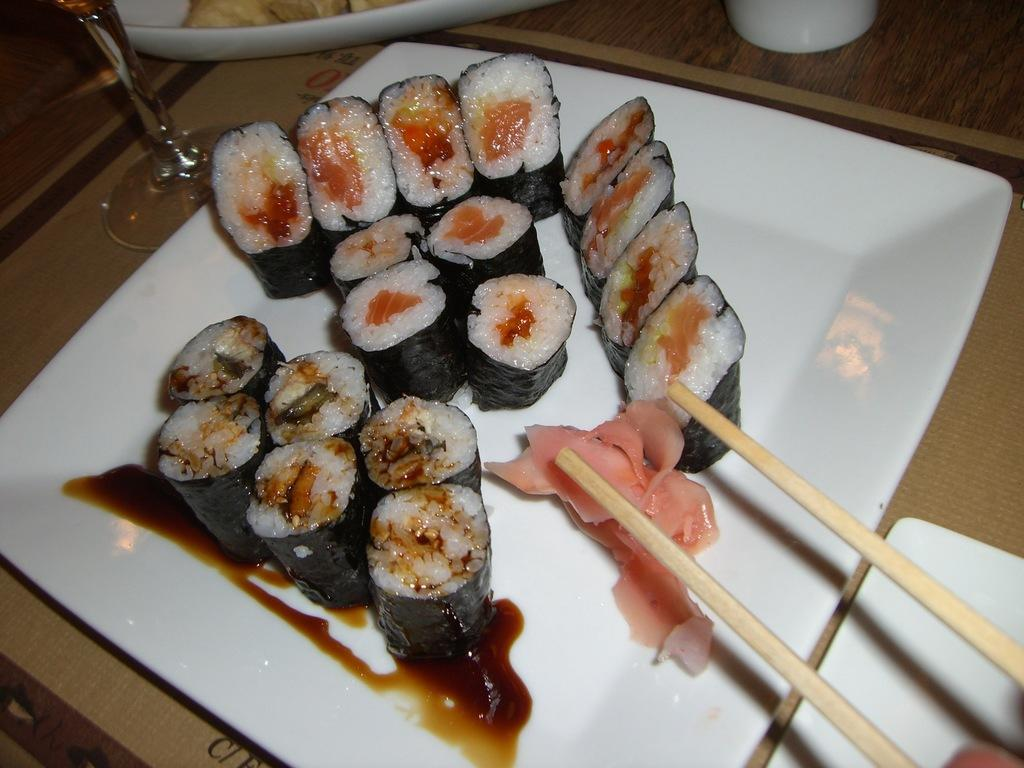What is present on the plate in the image? There is food on the plate in the image. What else can be seen in the image? There is a stick in the image. What language is being spoken by the food on the plate in the image? There is no indication in the image that any language is being spoken. --- Facts: 1. There is a car in the image. 2. The car is red. 3. There is a person standing next to the car. 4. The person is holding a phone. 5. There is a building in the background. Absurd Topics: dinosaur, ocean, volcano Conversation: What is the main subject in the image? There is a car in the image. Can you describe the car in the image? The car is red. What is the person doing next to the car in the image? The person is standing next to the car and holding a phone. What can be seen in the background of the image? There is a building in the background. Reasoning: Let's think step by step in order to produce the conversation. We start by identifying the main subject in the image, which is the car. Then, we describe the specific features of the car, such as its color, which is red. Next, we observe the actions of the person in the image, noting that they are standing next to the car and holding a phone. Finally, we describe the background of the image, which includes a building. We ensure that each question can be answered definitively with the information given. We avoid yes/no questions and ensure that the language is simple and clear. Absurd Question/Answer: Can you see a dinosaur in the image? There is no dinosaur present in the image. --- Facts: 1. There is a group of people in the image. 2. The people are wearing hats. 3. There is a table in the image. 4. There are plates with food on the table. 5. There is a dog near the table. Absurd Topics: unicorn, rainbow, magic wand Conversation: How many people are in the image? There is a group of people in the image. What are the people wearing in the image? The people are wearing hats. What can be seen on the table in the image? There are plates with food on the table. What is located near the table in the image? There is a dog near the table. Reasoning: Let's think step by step in order to produce the conversation. We start by identifying the main subject in the image, which is the group of people. Then, we describe the specific features of the people, such as their hats. Next, we observe the objects on the table in the image, noting that there are plates with food on the table. Finally, we describe the presence of a 